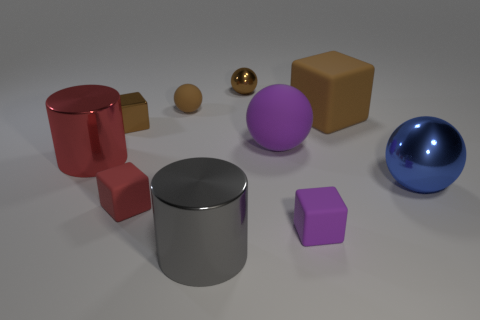Subtract all tiny purple matte cubes. How many cubes are left? 3 Subtract all purple spheres. How many spheres are left? 3 Subtract all blocks. How many objects are left? 6 Subtract 2 cubes. How many cubes are left? 2 Subtract all red spheres. Subtract all cyan blocks. How many spheres are left? 4 Subtract all red cubes. How many yellow spheres are left? 0 Add 8 big red shiny objects. How many big red shiny objects are left? 9 Add 9 tiny purple balls. How many tiny purple balls exist? 9 Subtract 0 cyan blocks. How many objects are left? 10 Subtract all large matte objects. Subtract all balls. How many objects are left? 4 